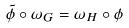<formula> <loc_0><loc_0><loc_500><loc_500>\tilde { \phi } \circ \omega _ { G } = \omega _ { H } \circ \phi</formula> 